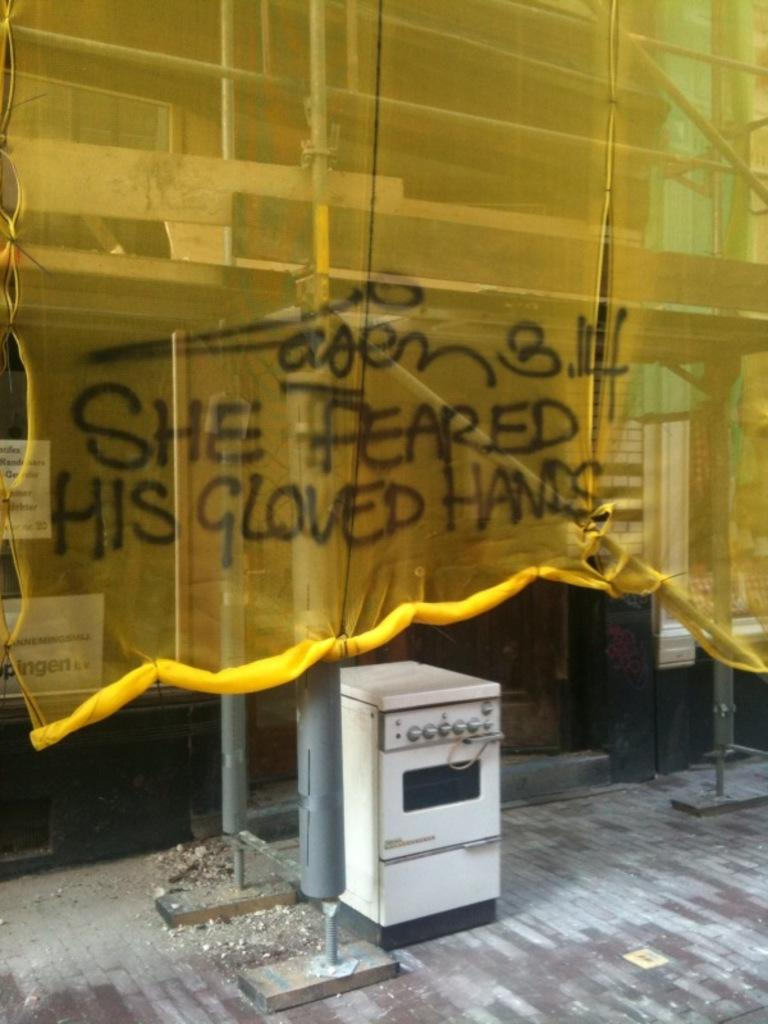<image>
Provide a brief description of the given image. Graffiti across a yellow curtain reads "She feared his gloved hands" 